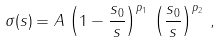<formula> <loc_0><loc_0><loc_500><loc_500>\sigma ( s ) = A \, \left ( 1 - \frac { s _ { 0 } } { s } \right ) ^ { p _ { 1 } } \, \left ( \frac { s _ { 0 } } { s } \right ) ^ { p _ { 2 } } \, ,</formula> 